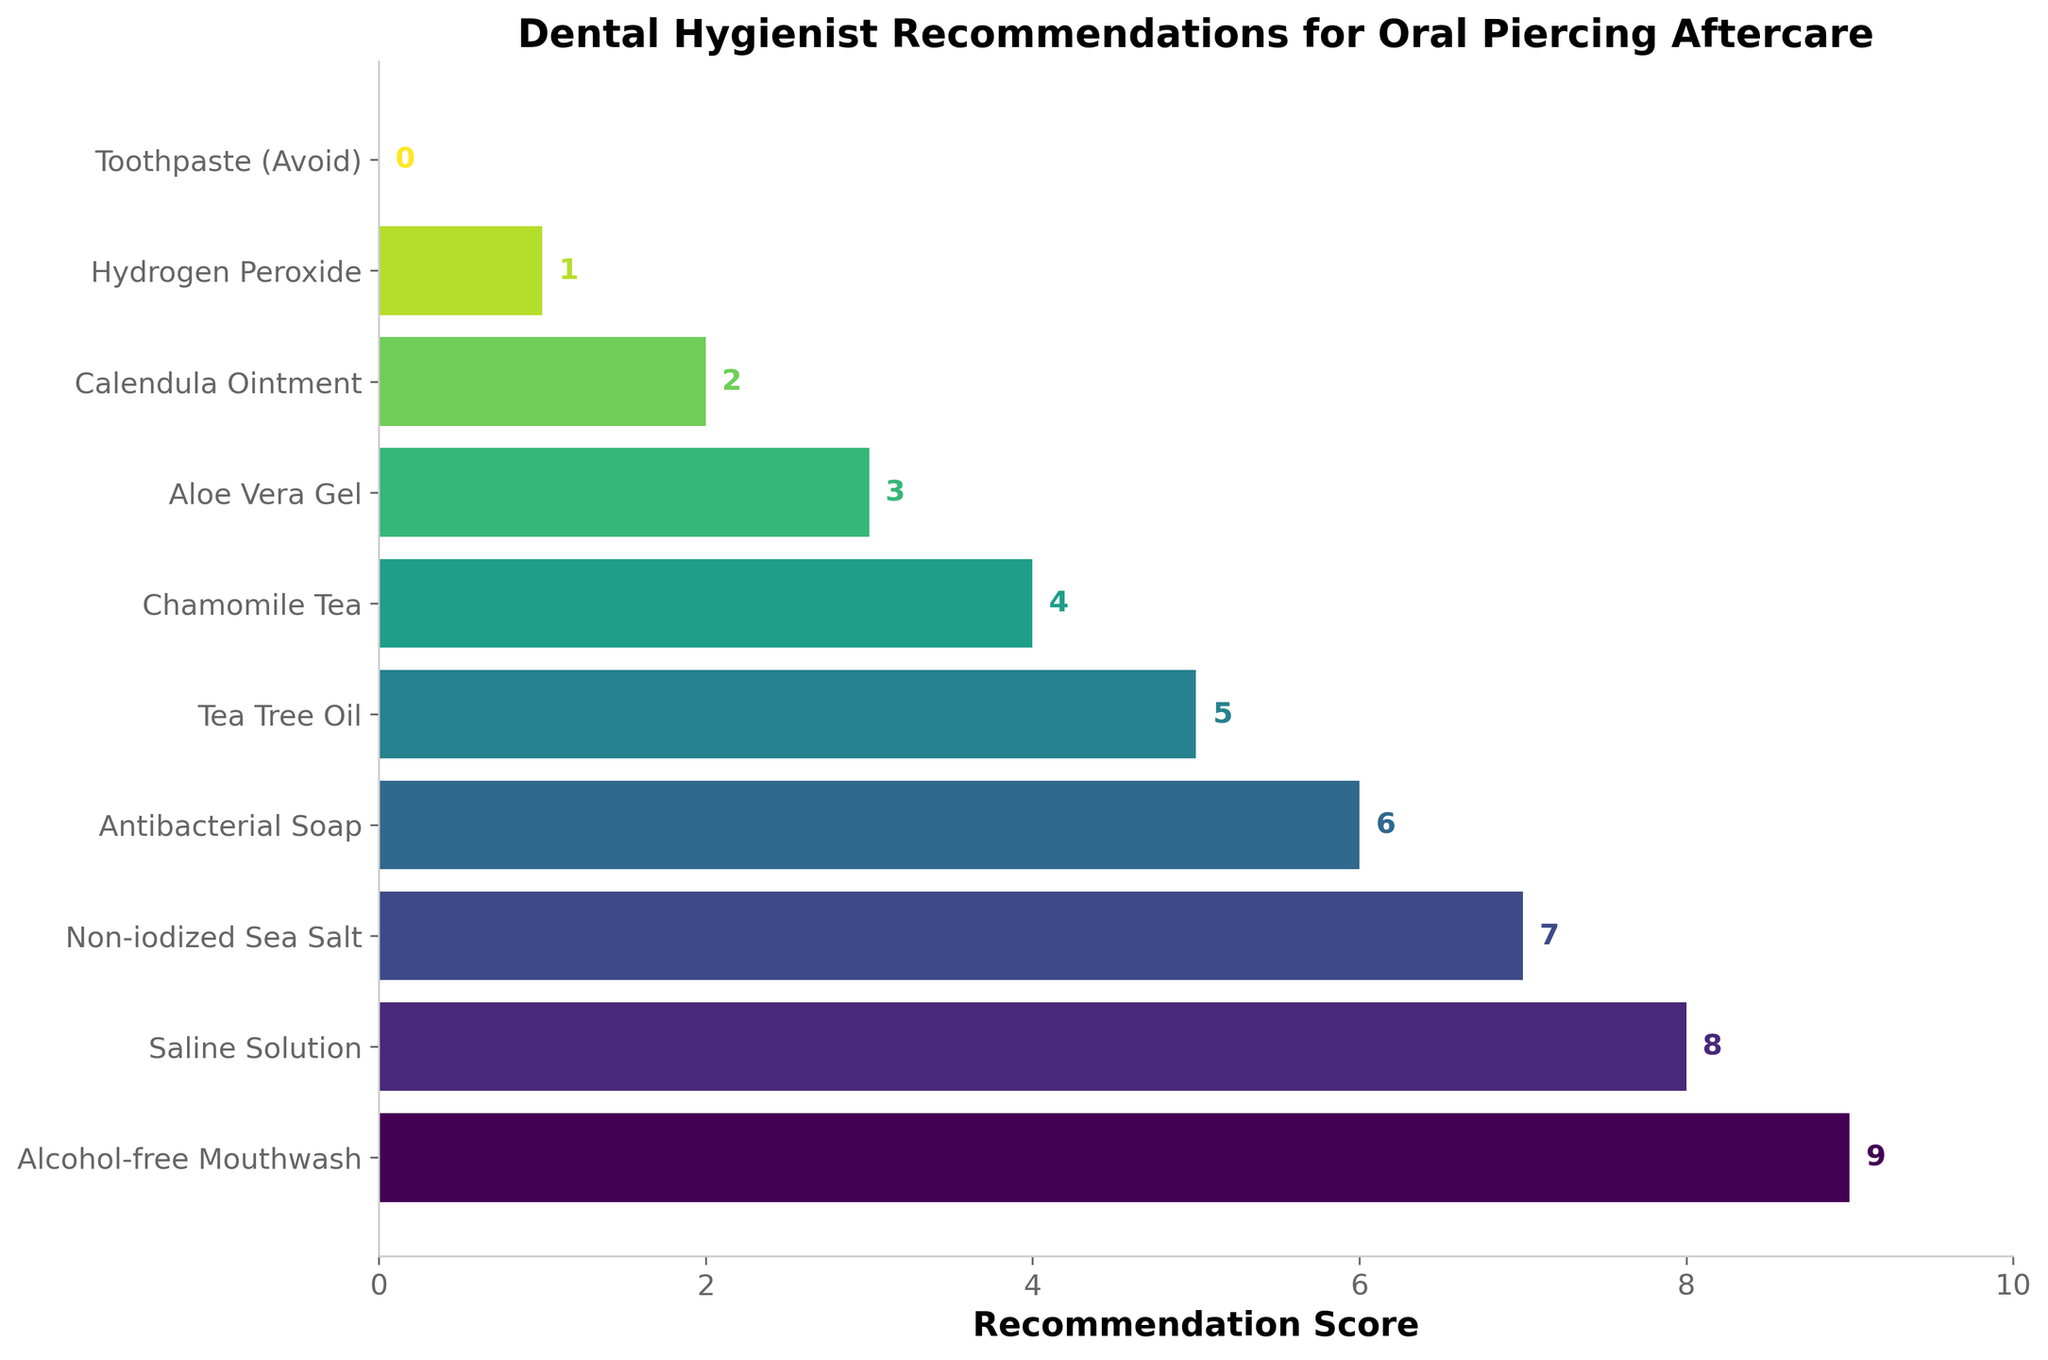What's the most highly recommended product for oral piercing aftercare? The bar with the highest recommendation score represents the most highly recommended product. The "Alcohol-free Mouthwash" bar is the tallest with a score of 9.
Answer: Alcohol-free Mouthwash Which product has a lower recommendation score: Tea Tree Oil or Aloe Vera Gel? The bar for Tea Tree Oil is taller (score of 5) compared to the bar for Aloe Vera Gel (score of 3).
Answer: Aloe Vera Gel What is the combined recommendation score of Chamomile Tea and Calendula Ointment? Add the scores for Chamomile Tea (4) and Calendula Ointment (2) for the combined score. 4 + 2 = 6.
Answer: 6 Which products are recommended more than Antibacterial Soap but less than Saline Solution? The bar for Antibacterial Soap has a score of 6 and Saline Solution has a score of 8. The product with scores between 6 and 8 is Non-iodized Sea Salt (7).
Answer: Non-iodized Sea Salt What is the difference in recommendation scores between the highest and lowest recommended products? The highest recommended product has a score of 9 (Alcohol-free Mouthwash) and the lowest has a score of 0 (Toothpaste). The difference is 9 - 0 = 9.
Answer: 9 Which product should be completely avoided according to the recommendation chart? The product with a recommendation score of 0 suggests it should be avoided. Toothpaste has a score of 0.
Answer: Toothpaste How many products have a recommendation score below 5? Count the bars with scores less than 5. They are Chamomile Tea (4), Aloe Vera Gel (3), Calendula Ointment (2), Hydrogen Peroxide (1), and Toothpaste (0).
Answer: 5 What is the average recommendation score of the top three recommended products? The top three products are Alcohol-free Mouthwash (9), Saline Solution (8), and Non-iodized Sea Salt (7). The average is (9 + 8 + 7) / 3 = 24 / 3 = 8.
Answer: 8 Which product is just one point below the recommendation score of Saline Solution? Saline Solution has a score of 8. The product with a score of 7, one point below, is Non-iodized Sea Salt.
Answer: Non-iodized Sea Salt What color are the bars representing products with recommendation scores below 4? Examine the color gradient used in the chart. For scores below 4, the products are Aloe Vera Gel (3), Calendula Ointment (2), and Hydrogen Peroxide (1). These bars are in the lightest shades.
Answer: Lightest shades 